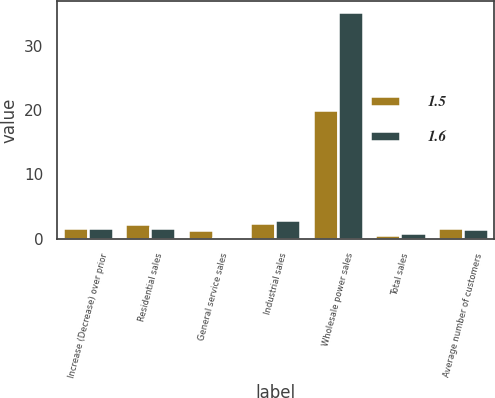Convert chart to OTSL. <chart><loc_0><loc_0><loc_500><loc_500><stacked_bar_chart><ecel><fcel>Increase (Decrease) over prior<fcel>Residential sales<fcel>General service sales<fcel>Industrial sales<fcel>Wholesale power sales<fcel>Total sales<fcel>Average number of customers<nl><fcel>1.5<fcel>1.65<fcel>2.3<fcel>1.3<fcel>2.4<fcel>20.1<fcel>0.5<fcel>1.6<nl><fcel>1.6<fcel>1.65<fcel>1.7<fcel>0.1<fcel>2.9<fcel>35.2<fcel>0.9<fcel>1.5<nl></chart> 